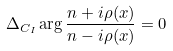<formula> <loc_0><loc_0><loc_500><loc_500>\Delta _ { C _ { I } } \arg \frac { n + i \rho ( x ) } { n - i \rho ( x ) } = 0</formula> 